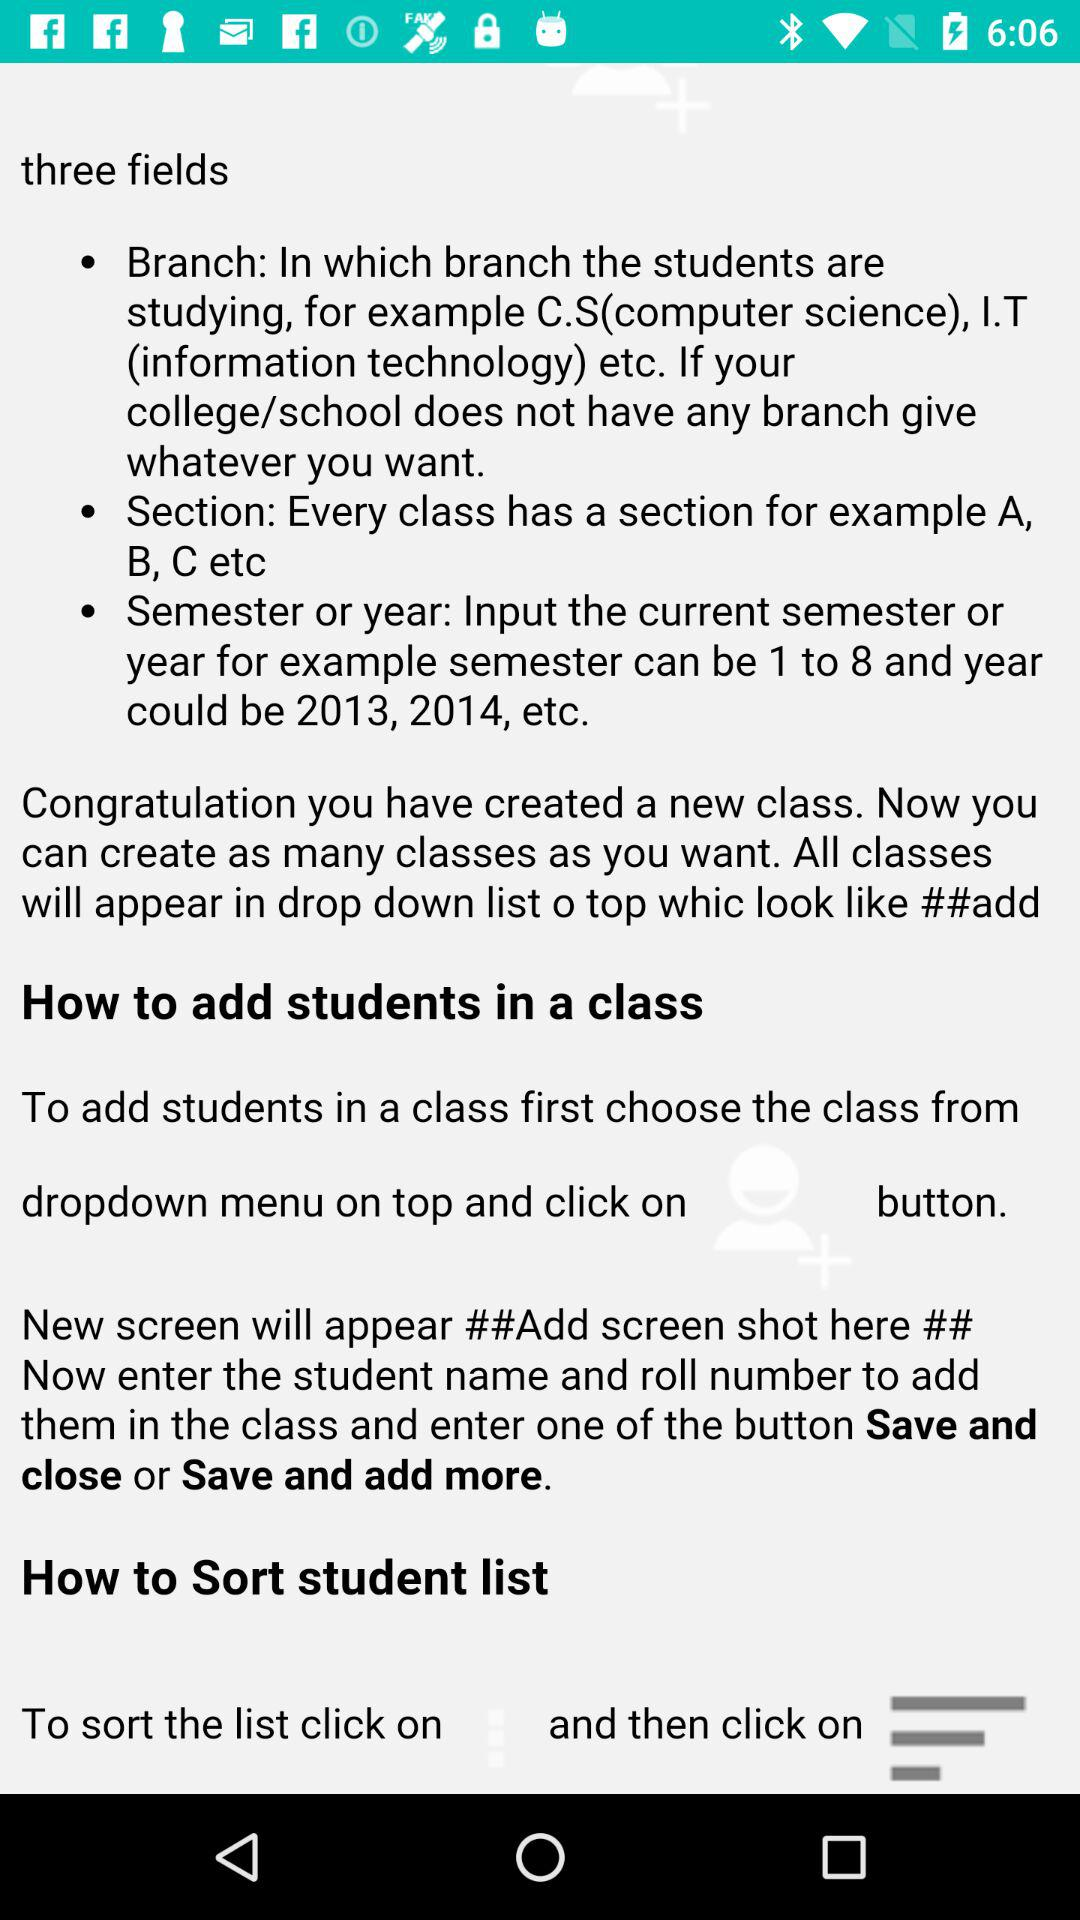Where do all the classes appear? All the classes appear in "drop down list o top whic look like ##add". 